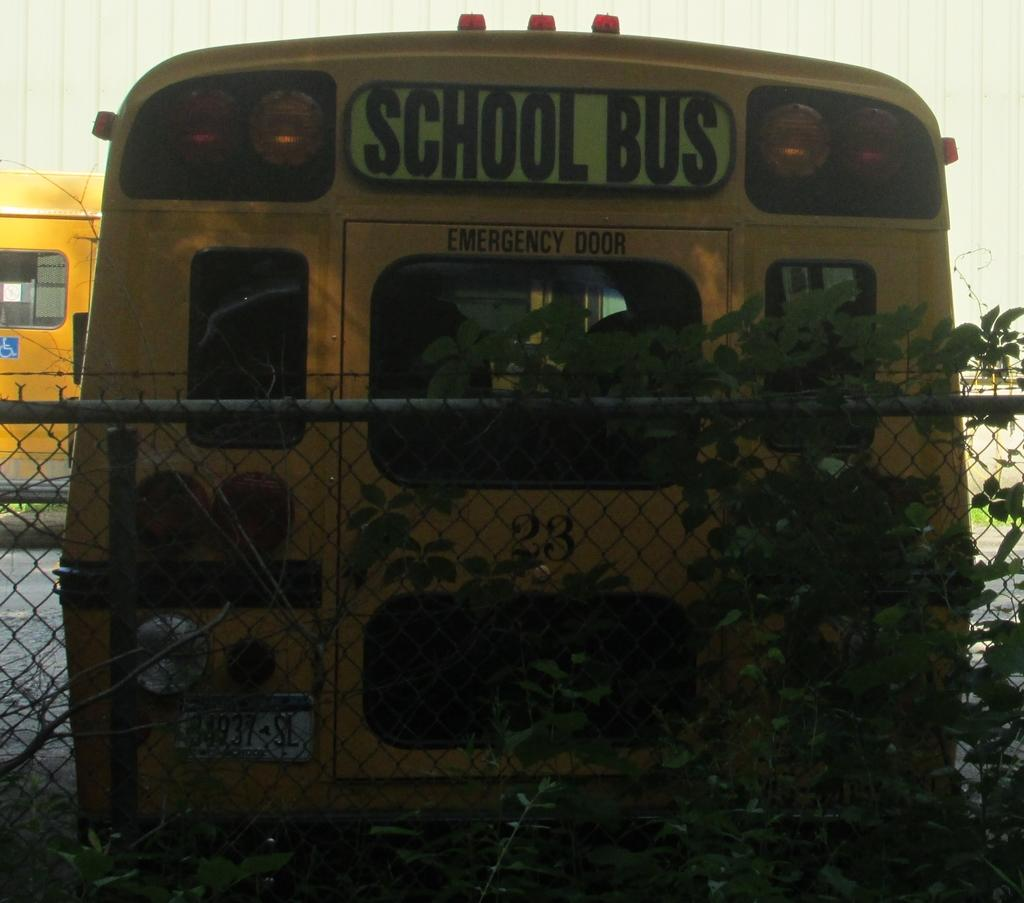<image>
Relay a brief, clear account of the picture shown. The rear of a school bus with the emergency door visible parked by a chain link fence. 